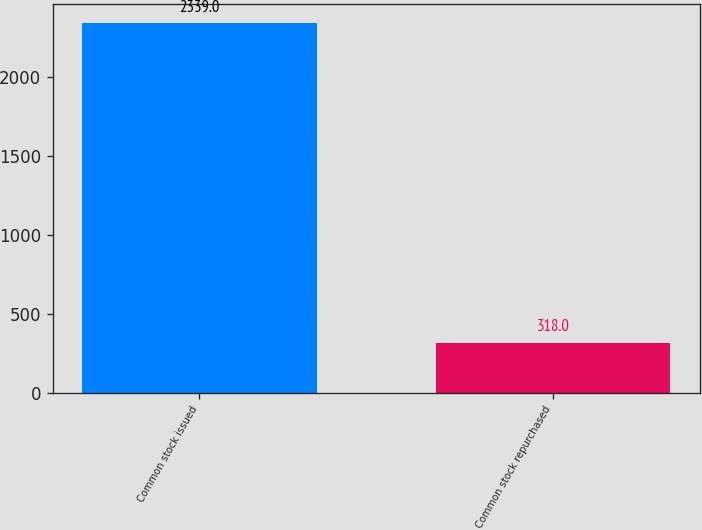<chart> <loc_0><loc_0><loc_500><loc_500><bar_chart><fcel>Common stock issued<fcel>Common stock repurchased<nl><fcel>2339<fcel>318<nl></chart> 